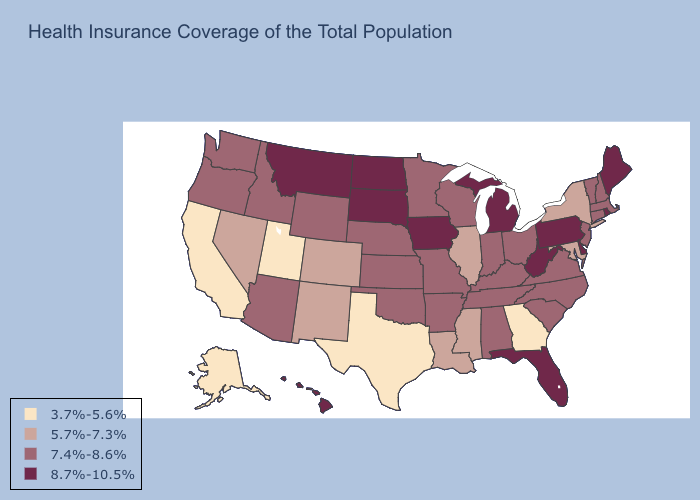Does the first symbol in the legend represent the smallest category?
Keep it brief. Yes. Does Colorado have a higher value than Georgia?
Short answer required. Yes. Does the map have missing data?
Write a very short answer. No. What is the highest value in states that border Colorado?
Keep it brief. 7.4%-8.6%. Name the states that have a value in the range 8.7%-10.5%?
Answer briefly. Delaware, Florida, Hawaii, Iowa, Maine, Michigan, Montana, North Dakota, Pennsylvania, Rhode Island, South Dakota, West Virginia. Which states have the lowest value in the USA?
Give a very brief answer. Alaska, California, Georgia, Texas, Utah. What is the value of Connecticut?
Write a very short answer. 7.4%-8.6%. Does Connecticut have a higher value than North Dakota?
Answer briefly. No. What is the lowest value in the South?
Concise answer only. 3.7%-5.6%. What is the value of Maine?
Short answer required. 8.7%-10.5%. Does Missouri have a lower value than Hawaii?
Quick response, please. Yes. Name the states that have a value in the range 8.7%-10.5%?
Give a very brief answer. Delaware, Florida, Hawaii, Iowa, Maine, Michigan, Montana, North Dakota, Pennsylvania, Rhode Island, South Dakota, West Virginia. What is the lowest value in the USA?
Answer briefly. 3.7%-5.6%. Which states have the highest value in the USA?
Give a very brief answer. Delaware, Florida, Hawaii, Iowa, Maine, Michigan, Montana, North Dakota, Pennsylvania, Rhode Island, South Dakota, West Virginia. Among the states that border Connecticut , does Rhode Island have the highest value?
Concise answer only. Yes. 